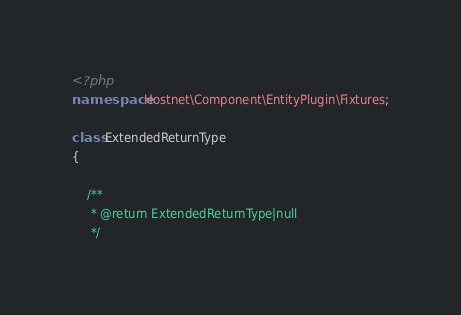Convert code to text. <code><loc_0><loc_0><loc_500><loc_500><_PHP_><?php
namespace Hostnet\Component\EntityPlugin\Fixtures;

class ExtendedReturnType
{

    /**
     * @return ExtendedReturnType|null
     */</code> 